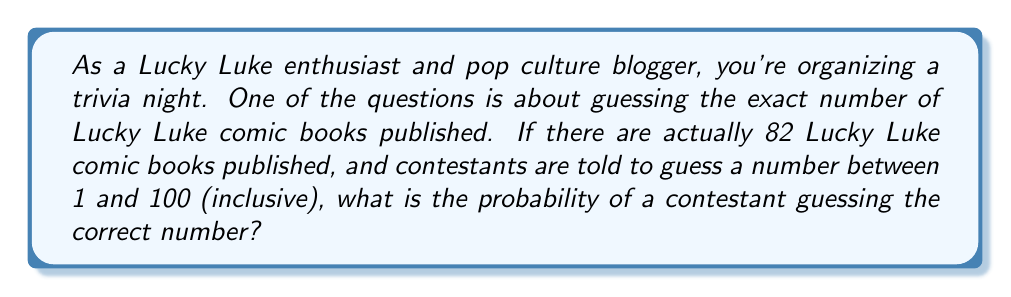Give your solution to this math problem. To solve this problem, we need to consider the following:

1. The total number of possible guesses: 100 (from 1 to 100, inclusive)
2. The number of correct guesses: 1 (only the number 82 is correct)

The probability of an event is calculated by dividing the number of favorable outcomes by the total number of possible outcomes, assuming all outcomes are equally likely.

In this case:

$$ P(\text{correct guess}) = \frac{\text{number of correct guesses}}{\text{total number of possible guesses}} $$

$$ P(\text{correct guess}) = \frac{1}{100} = 0.01 $$

This can also be expressed as a percentage:

$$ 0.01 \times 100\% = 1\% $$

Or as odds:

$$ \text{Odds} = \frac{1}{99} \text{ or } 1:99 $$

This means that for every 1 correct guess, we expect 99 incorrect guesses.
Answer: The probability of correctly guessing the number of Lucky Luke comic books published is $\frac{1}{100}$ or 0.01 or 1% or 1:99 odds. 